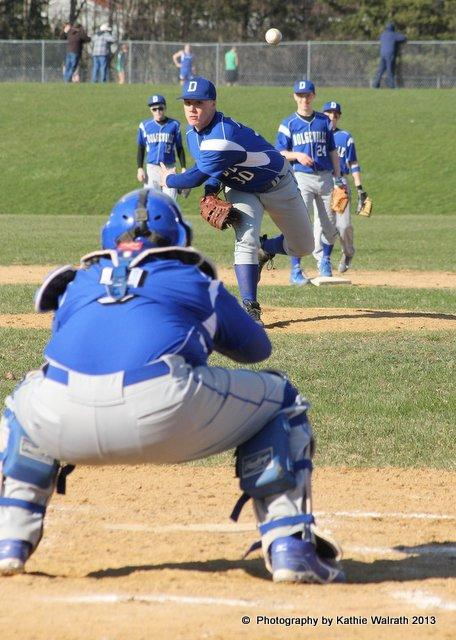What numbered player last touched the ball? 30 